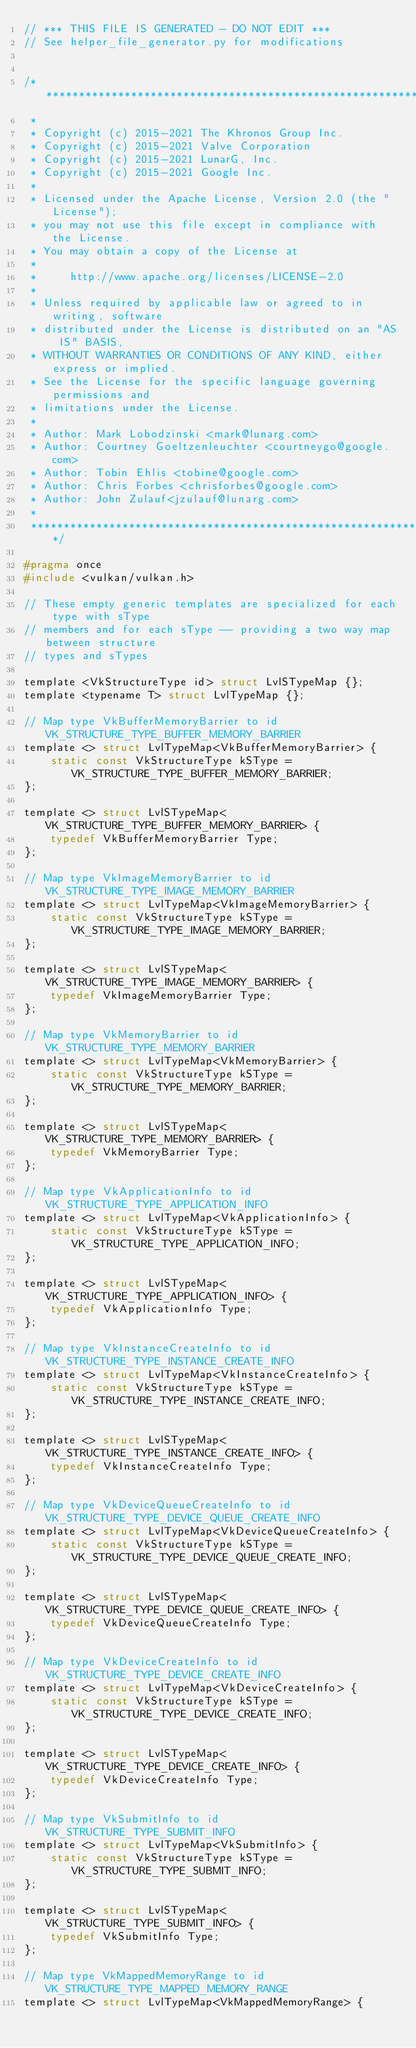<code> <loc_0><loc_0><loc_500><loc_500><_C_>// *** THIS FILE IS GENERATED - DO NOT EDIT ***
// See helper_file_generator.py for modifications


/***************************************************************************
 *
 * Copyright (c) 2015-2021 The Khronos Group Inc.
 * Copyright (c) 2015-2021 Valve Corporation
 * Copyright (c) 2015-2021 LunarG, Inc.
 * Copyright (c) 2015-2021 Google Inc.
 *
 * Licensed under the Apache License, Version 2.0 (the "License");
 * you may not use this file except in compliance with the License.
 * You may obtain a copy of the License at
 *
 *     http://www.apache.org/licenses/LICENSE-2.0
 *
 * Unless required by applicable law or agreed to in writing, software
 * distributed under the License is distributed on an "AS IS" BASIS,
 * WITHOUT WARRANTIES OR CONDITIONS OF ANY KIND, either express or implied.
 * See the License for the specific language governing permissions and
 * limitations under the License.
 *
 * Author: Mark Lobodzinski <mark@lunarg.com>
 * Author: Courtney Goeltzenleuchter <courtneygo@google.com>
 * Author: Tobin Ehlis <tobine@google.com>
 * Author: Chris Forbes <chrisforbes@google.com>
 * Author: John Zulauf<jzulauf@lunarg.com>
 *
 ****************************************************************************/

#pragma once
#include <vulkan/vulkan.h>

// These empty generic templates are specialized for each type with sType
// members and for each sType -- providing a two way map between structure
// types and sTypes

template <VkStructureType id> struct LvlSTypeMap {};
template <typename T> struct LvlTypeMap {};

// Map type VkBufferMemoryBarrier to id VK_STRUCTURE_TYPE_BUFFER_MEMORY_BARRIER
template <> struct LvlTypeMap<VkBufferMemoryBarrier> {
    static const VkStructureType kSType = VK_STRUCTURE_TYPE_BUFFER_MEMORY_BARRIER;
};

template <> struct LvlSTypeMap<VK_STRUCTURE_TYPE_BUFFER_MEMORY_BARRIER> {
    typedef VkBufferMemoryBarrier Type;
};

// Map type VkImageMemoryBarrier to id VK_STRUCTURE_TYPE_IMAGE_MEMORY_BARRIER
template <> struct LvlTypeMap<VkImageMemoryBarrier> {
    static const VkStructureType kSType = VK_STRUCTURE_TYPE_IMAGE_MEMORY_BARRIER;
};

template <> struct LvlSTypeMap<VK_STRUCTURE_TYPE_IMAGE_MEMORY_BARRIER> {
    typedef VkImageMemoryBarrier Type;
};

// Map type VkMemoryBarrier to id VK_STRUCTURE_TYPE_MEMORY_BARRIER
template <> struct LvlTypeMap<VkMemoryBarrier> {
    static const VkStructureType kSType = VK_STRUCTURE_TYPE_MEMORY_BARRIER;
};

template <> struct LvlSTypeMap<VK_STRUCTURE_TYPE_MEMORY_BARRIER> {
    typedef VkMemoryBarrier Type;
};

// Map type VkApplicationInfo to id VK_STRUCTURE_TYPE_APPLICATION_INFO
template <> struct LvlTypeMap<VkApplicationInfo> {
    static const VkStructureType kSType = VK_STRUCTURE_TYPE_APPLICATION_INFO;
};

template <> struct LvlSTypeMap<VK_STRUCTURE_TYPE_APPLICATION_INFO> {
    typedef VkApplicationInfo Type;
};

// Map type VkInstanceCreateInfo to id VK_STRUCTURE_TYPE_INSTANCE_CREATE_INFO
template <> struct LvlTypeMap<VkInstanceCreateInfo> {
    static const VkStructureType kSType = VK_STRUCTURE_TYPE_INSTANCE_CREATE_INFO;
};

template <> struct LvlSTypeMap<VK_STRUCTURE_TYPE_INSTANCE_CREATE_INFO> {
    typedef VkInstanceCreateInfo Type;
};

// Map type VkDeviceQueueCreateInfo to id VK_STRUCTURE_TYPE_DEVICE_QUEUE_CREATE_INFO
template <> struct LvlTypeMap<VkDeviceQueueCreateInfo> {
    static const VkStructureType kSType = VK_STRUCTURE_TYPE_DEVICE_QUEUE_CREATE_INFO;
};

template <> struct LvlSTypeMap<VK_STRUCTURE_TYPE_DEVICE_QUEUE_CREATE_INFO> {
    typedef VkDeviceQueueCreateInfo Type;
};

// Map type VkDeviceCreateInfo to id VK_STRUCTURE_TYPE_DEVICE_CREATE_INFO
template <> struct LvlTypeMap<VkDeviceCreateInfo> {
    static const VkStructureType kSType = VK_STRUCTURE_TYPE_DEVICE_CREATE_INFO;
};

template <> struct LvlSTypeMap<VK_STRUCTURE_TYPE_DEVICE_CREATE_INFO> {
    typedef VkDeviceCreateInfo Type;
};

// Map type VkSubmitInfo to id VK_STRUCTURE_TYPE_SUBMIT_INFO
template <> struct LvlTypeMap<VkSubmitInfo> {
    static const VkStructureType kSType = VK_STRUCTURE_TYPE_SUBMIT_INFO;
};

template <> struct LvlSTypeMap<VK_STRUCTURE_TYPE_SUBMIT_INFO> {
    typedef VkSubmitInfo Type;
};

// Map type VkMappedMemoryRange to id VK_STRUCTURE_TYPE_MAPPED_MEMORY_RANGE
template <> struct LvlTypeMap<VkMappedMemoryRange> {</code> 